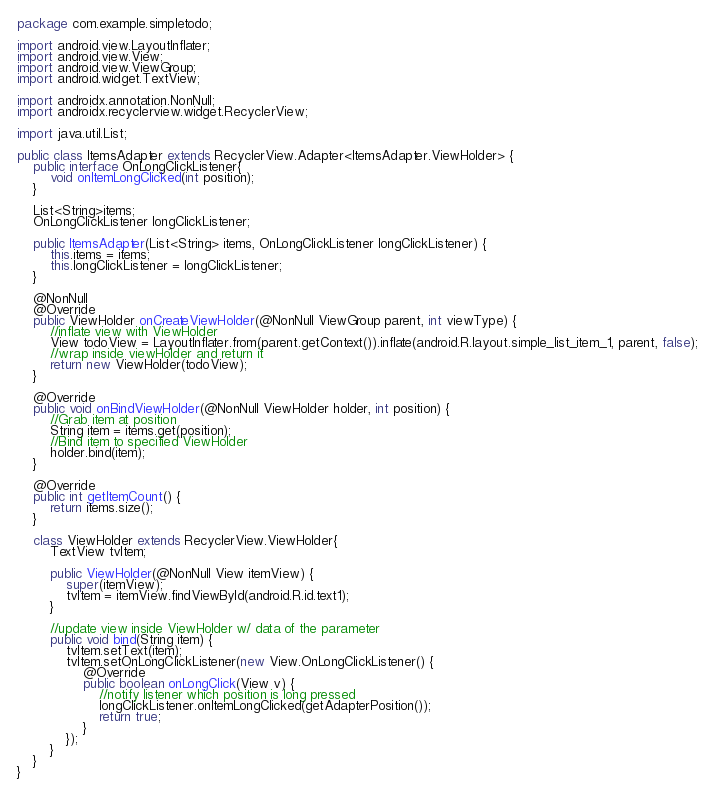<code> <loc_0><loc_0><loc_500><loc_500><_Java_>package com.example.simpletodo;

import android.view.LayoutInflater;
import android.view.View;
import android.view.ViewGroup;
import android.widget.TextView;

import androidx.annotation.NonNull;
import androidx.recyclerview.widget.RecyclerView;

import java.util.List;

public class ItemsAdapter extends RecyclerView.Adapter<ItemsAdapter.ViewHolder> {
    public interface OnLongClickListener{
        void onItemLongClicked(int position);
    }

    List<String>items;
    OnLongClickListener longClickListener;

    public ItemsAdapter(List<String> items, OnLongClickListener longClickListener) {
        this.items = items;
        this.longClickListener = longClickListener;
    }

    @NonNull
    @Override
    public ViewHolder onCreateViewHolder(@NonNull ViewGroup parent, int viewType) {
        //inflate view with ViewHolder
        View todoView = LayoutInflater.from(parent.getContext()).inflate(android.R.layout.simple_list_item_1, parent, false);
        //wrap inside viewHolder and return it
        return new ViewHolder(todoView);
    }

    @Override
    public void onBindViewHolder(@NonNull ViewHolder holder, int position) {
        //Grab item at position
        String item = items.get(position);
        //Bind item to specified ViewHolder
        holder.bind(item);
    }

    @Override
    public int getItemCount() {
        return items.size();
    }

    class ViewHolder extends RecyclerView.ViewHolder{
        TextView tvItem;

        public ViewHolder(@NonNull View itemView) {
            super(itemView);
            tvItem = itemView.findViewById(android.R.id.text1);
        }

        //update view inside ViewHolder w/ data of the parameter
        public void bind(String item) {
            tvItem.setText(item);
            tvItem.setOnLongClickListener(new View.OnLongClickListener() {
                @Override
                public boolean onLongClick(View v) {
                    //notify listener which position is long pressed
                    longClickListener.onItemLongClicked(getAdapterPosition());
                    return true;
                }
            });
        }
    }
}
</code> 